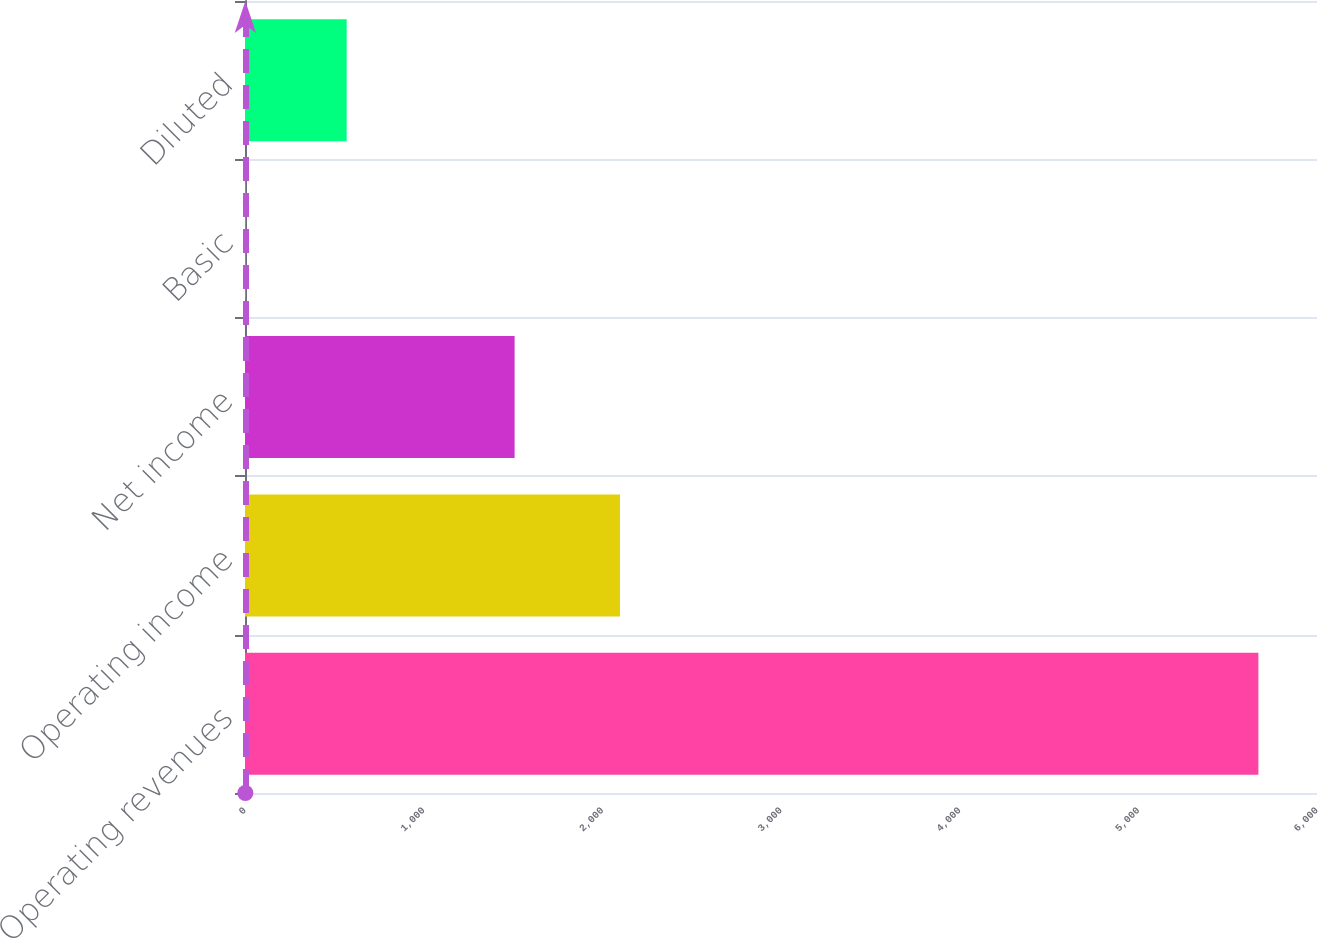<chart> <loc_0><loc_0><loc_500><loc_500><bar_chart><fcel>Operating revenues<fcel>Operating income<fcel>Net income<fcel>Basic<fcel>Diluted<nl><fcel>5672<fcel>2099<fcel>1509<fcel>1.98<fcel>568.98<nl></chart> 